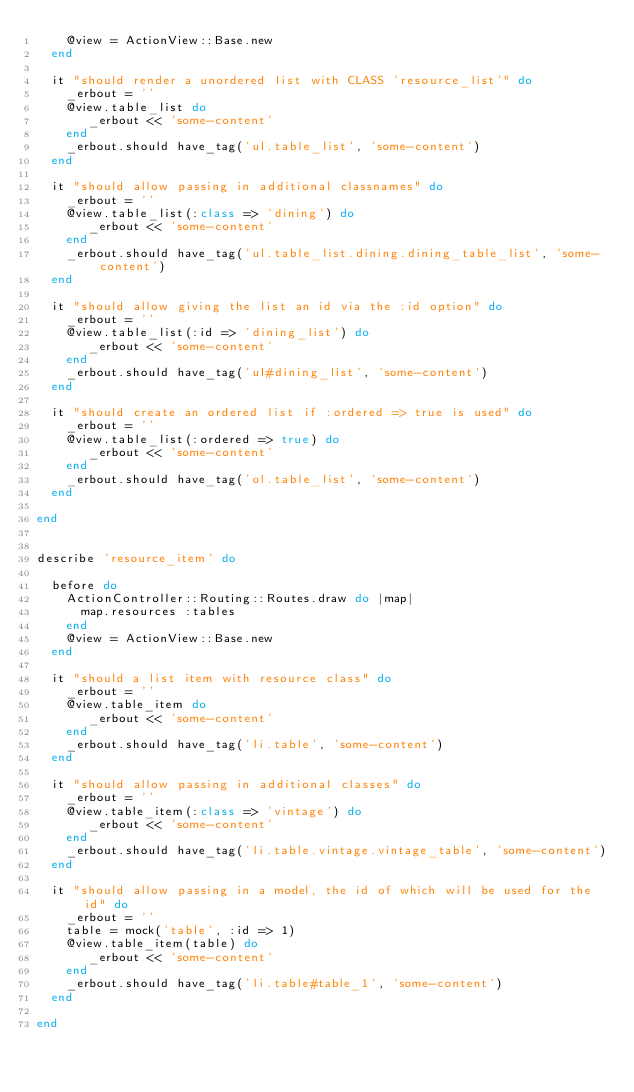<code> <loc_0><loc_0><loc_500><loc_500><_Ruby_>    @view = ActionView::Base.new
  end
  
  it "should render a unordered list with CLASS 'resource_list'" do
    _erbout = ''
    @view.table_list do
       _erbout << 'some-content'
    end
    _erbout.should have_tag('ul.table_list', 'some-content')
  end
  
  it "should allow passing in additional classnames" do
    _erbout = ''
    @view.table_list(:class => 'dining') do
       _erbout << 'some-content'
    end
    _erbout.should have_tag('ul.table_list.dining.dining_table_list', 'some-content')
  end
  
  it "should allow giving the list an id via the :id option" do
    _erbout = ''
    @view.table_list(:id => 'dining_list') do
       _erbout << 'some-content'
    end
    _erbout.should have_tag('ul#dining_list', 'some-content')
  end
  
  it "should create an ordered list if :ordered => true is used" do
    _erbout = ''
    @view.table_list(:ordered => true) do
       _erbout << 'some-content'
    end
    _erbout.should have_tag('ol.table_list', 'some-content')
  end
  
end


describe 'resource_item' do
  
  before do
    ActionController::Routing::Routes.draw do |map|
      map.resources :tables
    end
    @view = ActionView::Base.new
  end
  
  it "should a list item with resource class" do
    _erbout = ''
    @view.table_item do
       _erbout << 'some-content'
    end
    _erbout.should have_tag('li.table', 'some-content')
  end
  
  it "should allow passing in additional classes" do
    _erbout = ''
    @view.table_item(:class => 'vintage') do
       _erbout << 'some-content'
    end
    _erbout.should have_tag('li.table.vintage.vintage_table', 'some-content')
  end
  
  it "should allow passing in a model, the id of which will be used for the id" do
    _erbout = ''
    table = mock('table', :id => 1)
    @view.table_item(table) do
       _erbout << 'some-content'
    end
    _erbout.should have_tag('li.table#table_1', 'some-content')
  end
  
end




</code> 